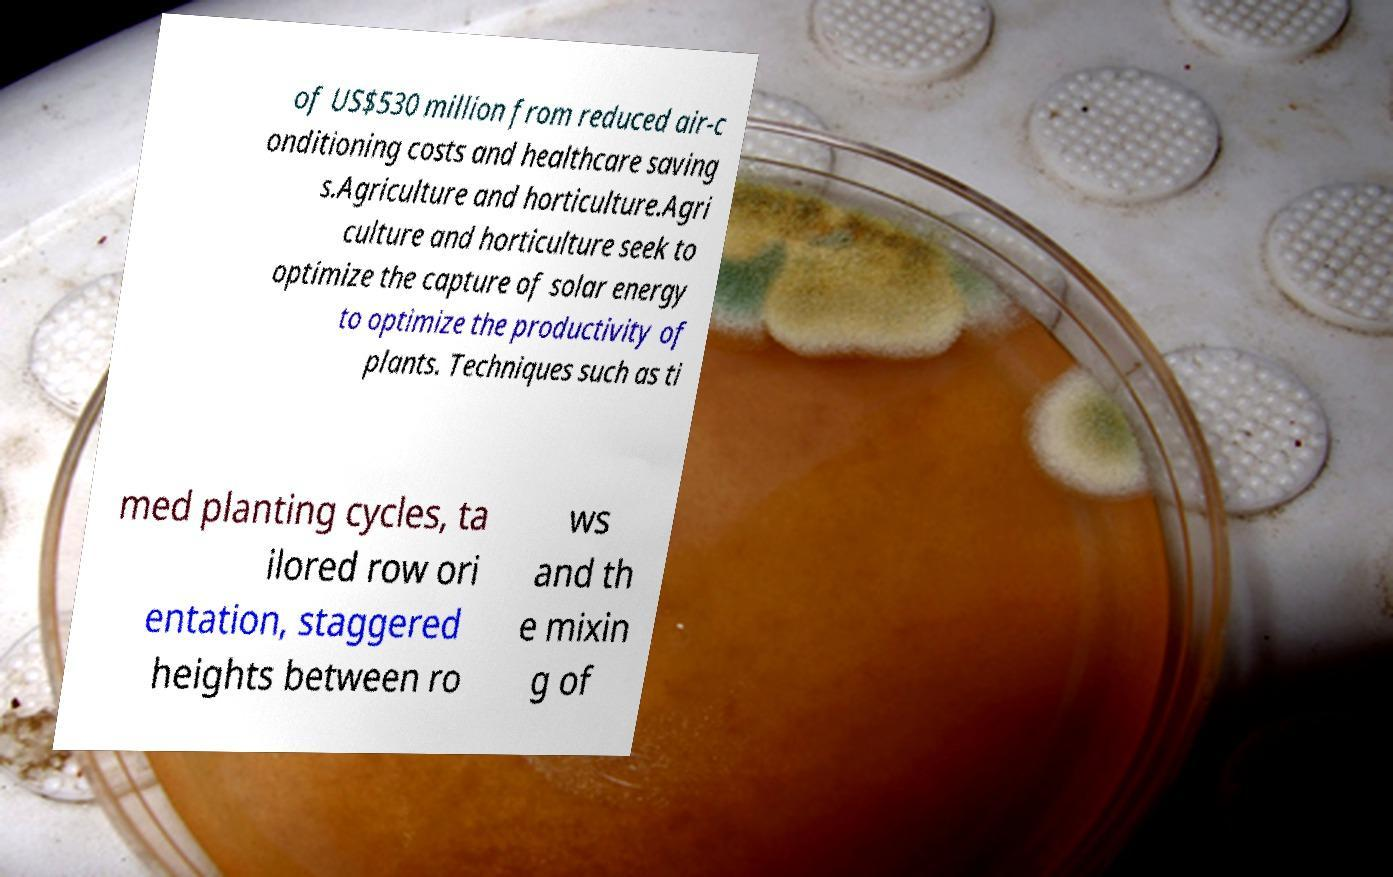Can you accurately transcribe the text from the provided image for me? of US$530 million from reduced air-c onditioning costs and healthcare saving s.Agriculture and horticulture.Agri culture and horticulture seek to optimize the capture of solar energy to optimize the productivity of plants. Techniques such as ti med planting cycles, ta ilored row ori entation, staggered heights between ro ws and th e mixin g of 